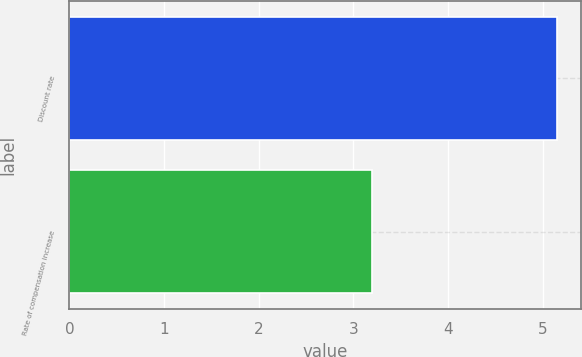Convert chart. <chart><loc_0><loc_0><loc_500><loc_500><bar_chart><fcel>Discount rate<fcel>Rate of compensation increase<nl><fcel>5.15<fcel>3.2<nl></chart> 